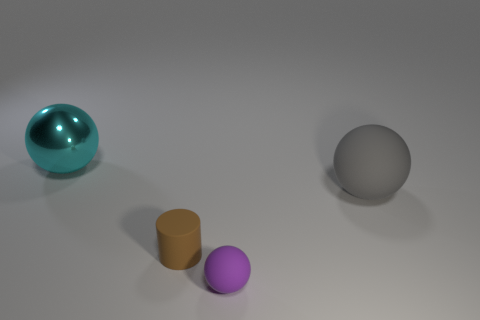Subtract all red cubes. How many green cylinders are left? 0 Subtract all tiny red rubber cylinders. Subtract all big metal things. How many objects are left? 3 Add 1 tiny rubber balls. How many tiny rubber balls are left? 2 Add 4 small yellow matte cylinders. How many small yellow matte cylinders exist? 4 Add 2 large gray cubes. How many objects exist? 6 Subtract all rubber balls. How many balls are left? 1 Subtract 1 brown cylinders. How many objects are left? 3 Subtract all balls. How many objects are left? 1 Subtract 2 balls. How many balls are left? 1 Subtract all green cylinders. Subtract all blue blocks. How many cylinders are left? 1 